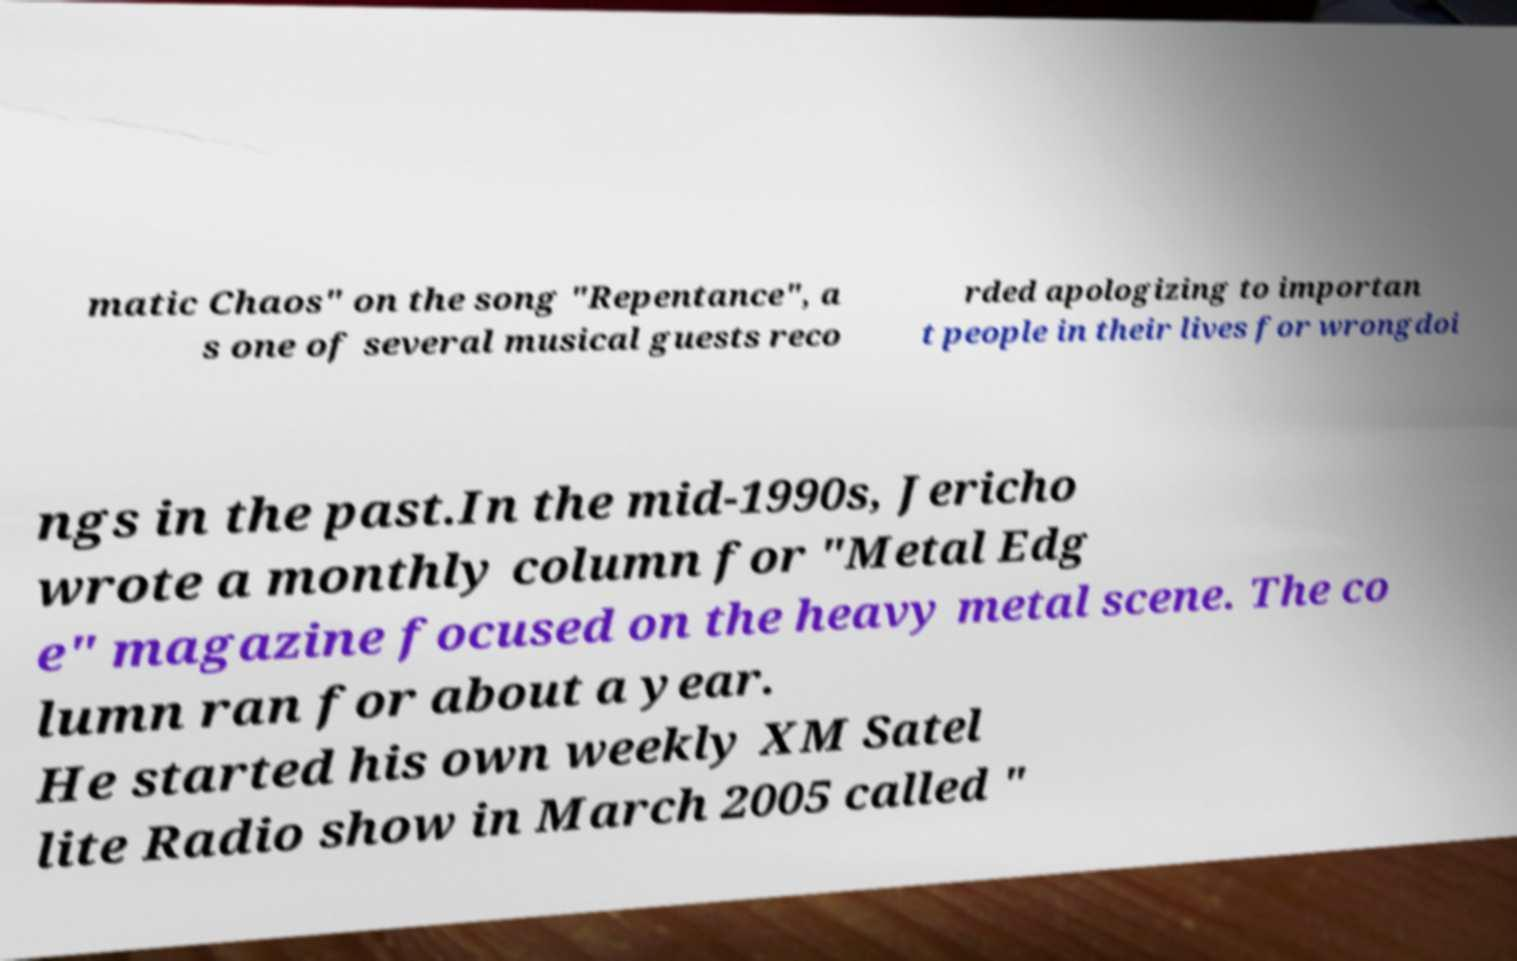For documentation purposes, I need the text within this image transcribed. Could you provide that? matic Chaos" on the song "Repentance", a s one of several musical guests reco rded apologizing to importan t people in their lives for wrongdoi ngs in the past.In the mid-1990s, Jericho wrote a monthly column for "Metal Edg e" magazine focused on the heavy metal scene. The co lumn ran for about a year. He started his own weekly XM Satel lite Radio show in March 2005 called " 